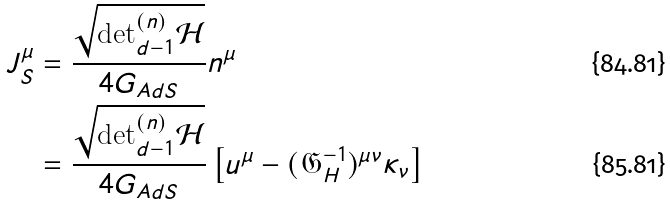Convert formula to latex. <formula><loc_0><loc_0><loc_500><loc_500>J ^ { \mu } _ { S } & = \frac { \sqrt { \text {det} ^ { ( n ) } _ { d - 1 } \mathcal { H } } } { 4 G _ { A d S } } n ^ { \mu } \\ & = \frac { \sqrt { \text {det} ^ { ( n ) } _ { d - 1 } \mathcal { H } } } { 4 G _ { A d S } } \left [ u ^ { \mu } - ( \mathfrak { G } _ { H } ^ { - 1 } ) ^ { \mu \nu } \kappa _ { \nu } \right ]</formula> 